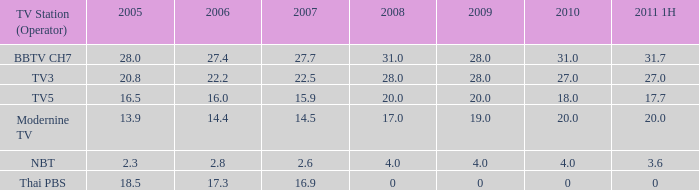How many 2011 1h values possess a 2006 of 2 0.0. 